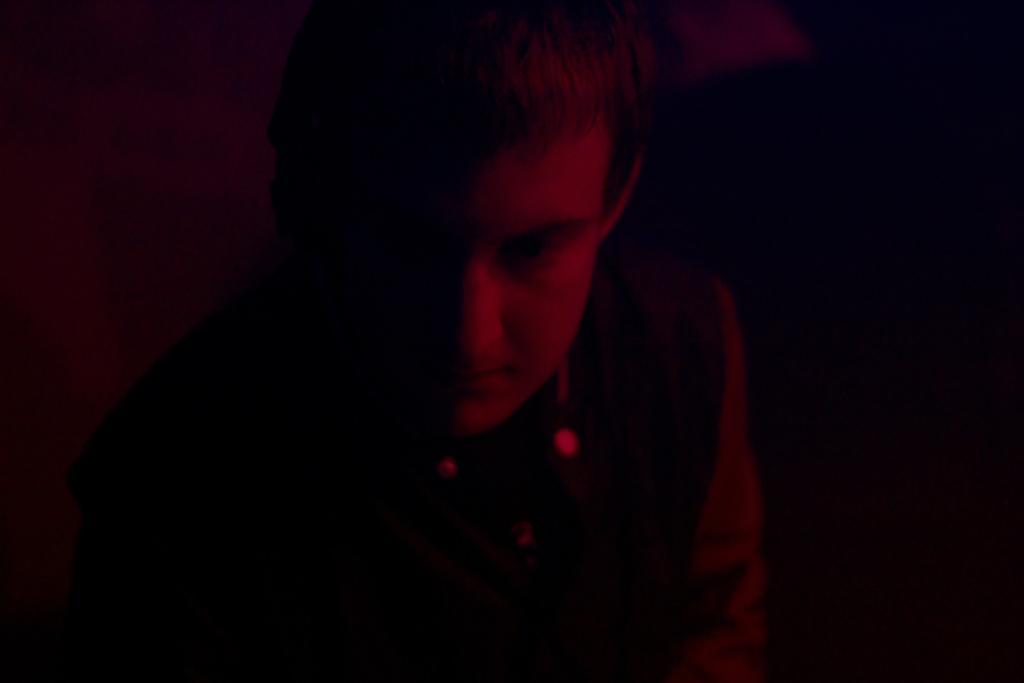In one or two sentences, can you explain what this image depicts? In this image in the foreground there is one person, and in the background there is a wall and some objects. 